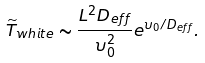<formula> <loc_0><loc_0><loc_500><loc_500>\widetilde { T } _ { w h i t e } \sim \frac { L ^ { 2 } D _ { e f f } } { \upsilon _ { 0 } ^ { 2 } } e ^ { \upsilon _ { 0 } / D _ { e f f } } .</formula> 